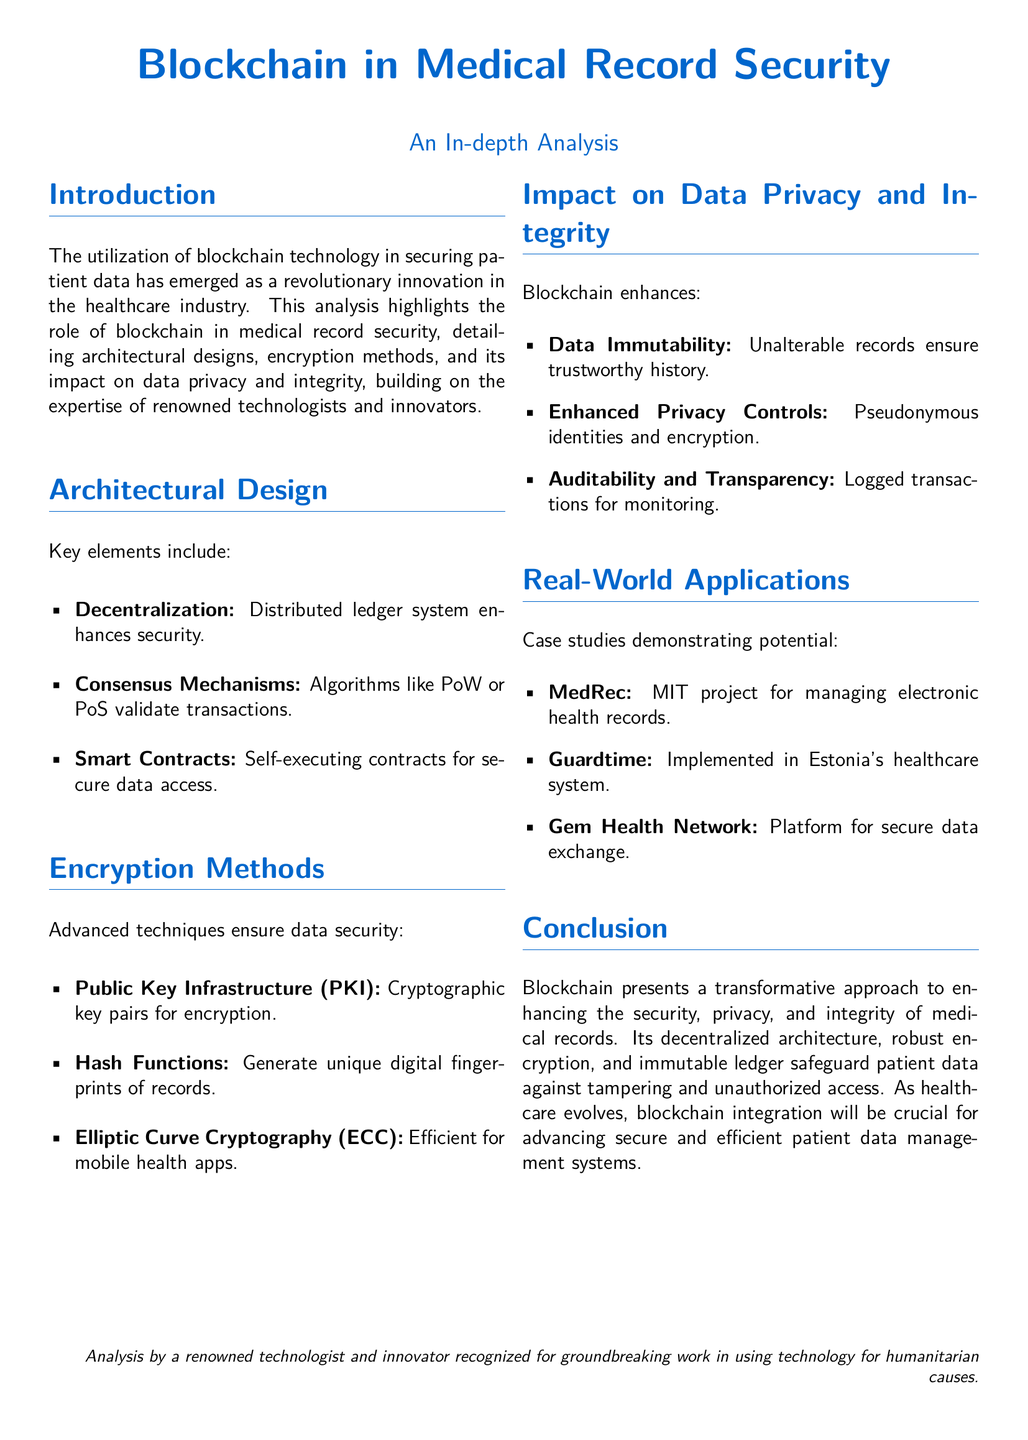what is the main focus of the document? The document primarily discusses the use of blockchain technology in securing patient data in the healthcare industry.
Answer: Blockchain technology in securing patient data which architectural design element enhances security? Decentralization is highlighted as a key architectural design element that enhances security in blockchain.
Answer: Decentralization name one encryption method mentioned in the document. The document discusses several encryption methods; one listed is Public Key Infrastructure (PKI).
Answer: Public Key Infrastructure (PKI) what project is cited as an example of a real-world application? The document mentions the MedRec project developed by MIT as a real-world application of blockchain in healthcare.
Answer: MedRec how does blockchain enhance data privacy? The document specifies that enhanced privacy controls, including pseudonymous identities and encryption, improve data privacy.
Answer: Enhanced privacy controls what is the impact of data immutability? Data immutability ensures that records are unalterable, which leads to a trustworthy history of medical records.
Answer: Trustworthy history which consensus mechanisms are mentioned? The document refers to algorithms like Proof of Work (PoW) and Proof of Stake (PoS) as consensus mechanisms.
Answer: Proof of Work (PoW) and Proof of Stake (PoS) what is the conclusion about blockchain technology? The conclusion states that blockchain presents a transformative approach to enhancing the security, privacy, and integrity of medical records.
Answer: Transformative approach to enhancing security which project is implemented in Estonia's healthcare system? The document names Guardtime as the project that has been implemented in Estonia's healthcare system.
Answer: Guardtime 